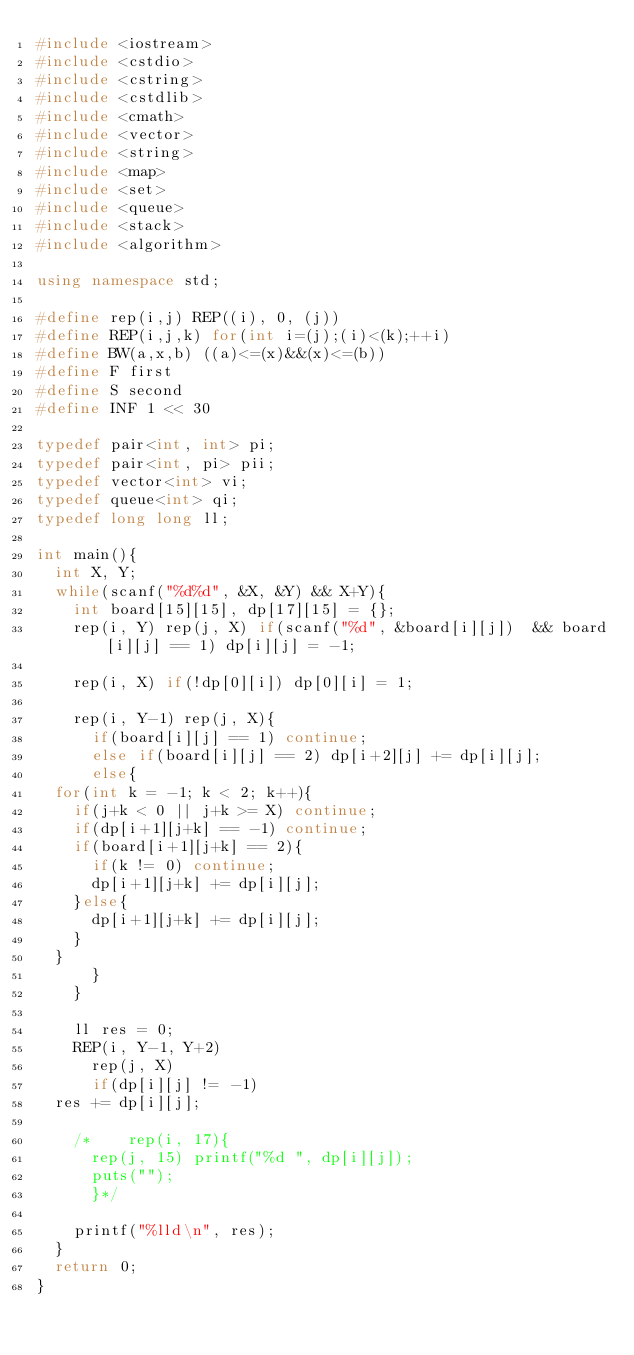Convert code to text. <code><loc_0><loc_0><loc_500><loc_500><_C++_>#include <iostream>
#include <cstdio>
#include <cstring>
#include <cstdlib>
#include <cmath>
#include <vector>
#include <string>
#include <map>
#include <set>
#include <queue>
#include <stack>
#include <algorithm>

using namespace std;

#define rep(i,j) REP((i), 0, (j))
#define REP(i,j,k) for(int i=(j);(i)<(k);++i)
#define BW(a,x,b) ((a)<=(x)&&(x)<=(b))
#define F first
#define S second
#define INF 1 << 30

typedef pair<int, int> pi;
typedef pair<int, pi> pii;
typedef vector<int> vi;
typedef queue<int> qi;
typedef long long ll;

int main(){
  int X, Y;
  while(scanf("%d%d", &X, &Y) && X+Y){
    int board[15][15], dp[17][15] = {};
    rep(i, Y) rep(j, X) if(scanf("%d", &board[i][j])  && board[i][j] == 1) dp[i][j] = -1;

    rep(i, X) if(!dp[0][i]) dp[0][i] = 1;

    rep(i, Y-1) rep(j, X){
      if(board[i][j] == 1) continue;
      else if(board[i][j] == 2) dp[i+2][j] += dp[i][j];
      else{
	for(int k = -1; k < 2; k++){
	  if(j+k < 0 || j+k >= X) continue;
	  if(dp[i+1][j+k] == -1) continue;
	  if(board[i+1][j+k] == 2){
	    if(k != 0) continue;
	    dp[i+1][j+k] += dp[i][j];
	  }else{
	    dp[i+1][j+k] += dp[i][j];
	  }
	}
      }
    }

    ll res = 0;
    REP(i, Y-1, Y+2)
      rep(j, X)
      if(dp[i][j] != -1)
	res += dp[i][j];
  
    /*    rep(i, 17){ 
      rep(j, 15) printf("%d ", dp[i][j]);
      puts("");
      }*/

    printf("%lld\n", res);
  }
  return 0;
}</code> 